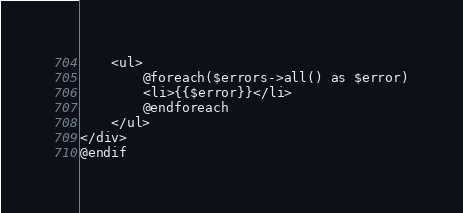<code> <loc_0><loc_0><loc_500><loc_500><_PHP_>    <ul>
        @foreach($errors->all() as $error)
        <li>{{$error}}</li>
        @endforeach
    </ul>
</div>
@endif
</code> 